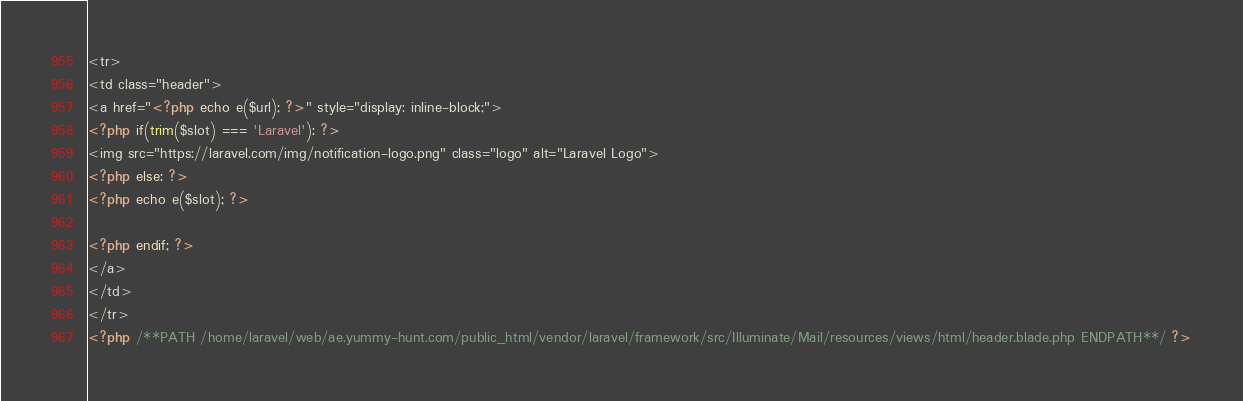Convert code to text. <code><loc_0><loc_0><loc_500><loc_500><_PHP_><tr>
<td class="header">
<a href="<?php echo e($url); ?>" style="display: inline-block;">
<?php if(trim($slot) === 'Laravel'): ?>
<img src="https://laravel.com/img/notification-logo.png" class="logo" alt="Laravel Logo">
<?php else: ?>
<?php echo e($slot); ?>

<?php endif; ?>
</a>
</td>
</tr>
<?php /**PATH /home/laravel/web/ae.yummy-hunt.com/public_html/vendor/laravel/framework/src/Illuminate/Mail/resources/views/html/header.blade.php ENDPATH**/ ?></code> 